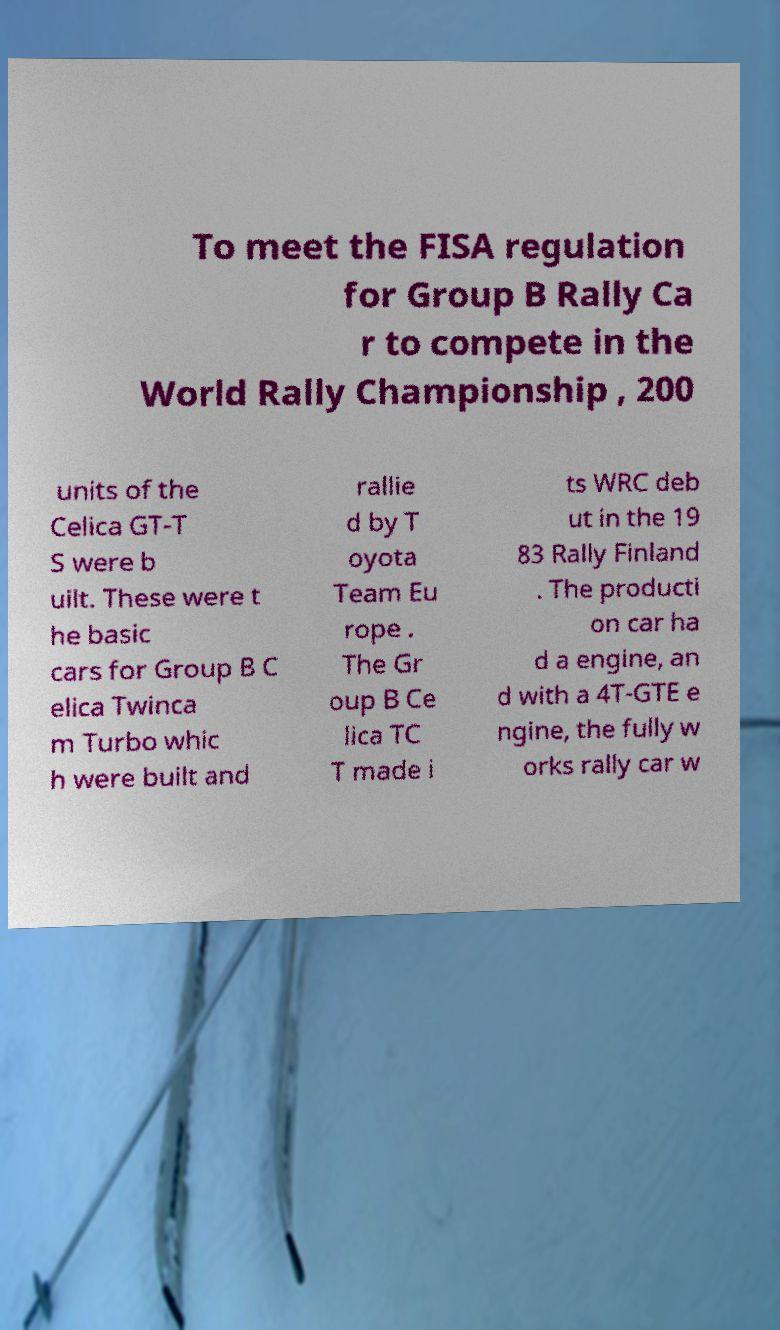Can you read and provide the text displayed in the image?This photo seems to have some interesting text. Can you extract and type it out for me? To meet the FISA regulation for Group B Rally Ca r to compete in the World Rally Championship , 200 units of the Celica GT-T S were b uilt. These were t he basic cars for Group B C elica Twinca m Turbo whic h were built and rallie d by T oyota Team Eu rope . The Gr oup B Ce lica TC T made i ts WRC deb ut in the 19 83 Rally Finland . The producti on car ha d a engine, an d with a 4T-GTE e ngine, the fully w orks rally car w 